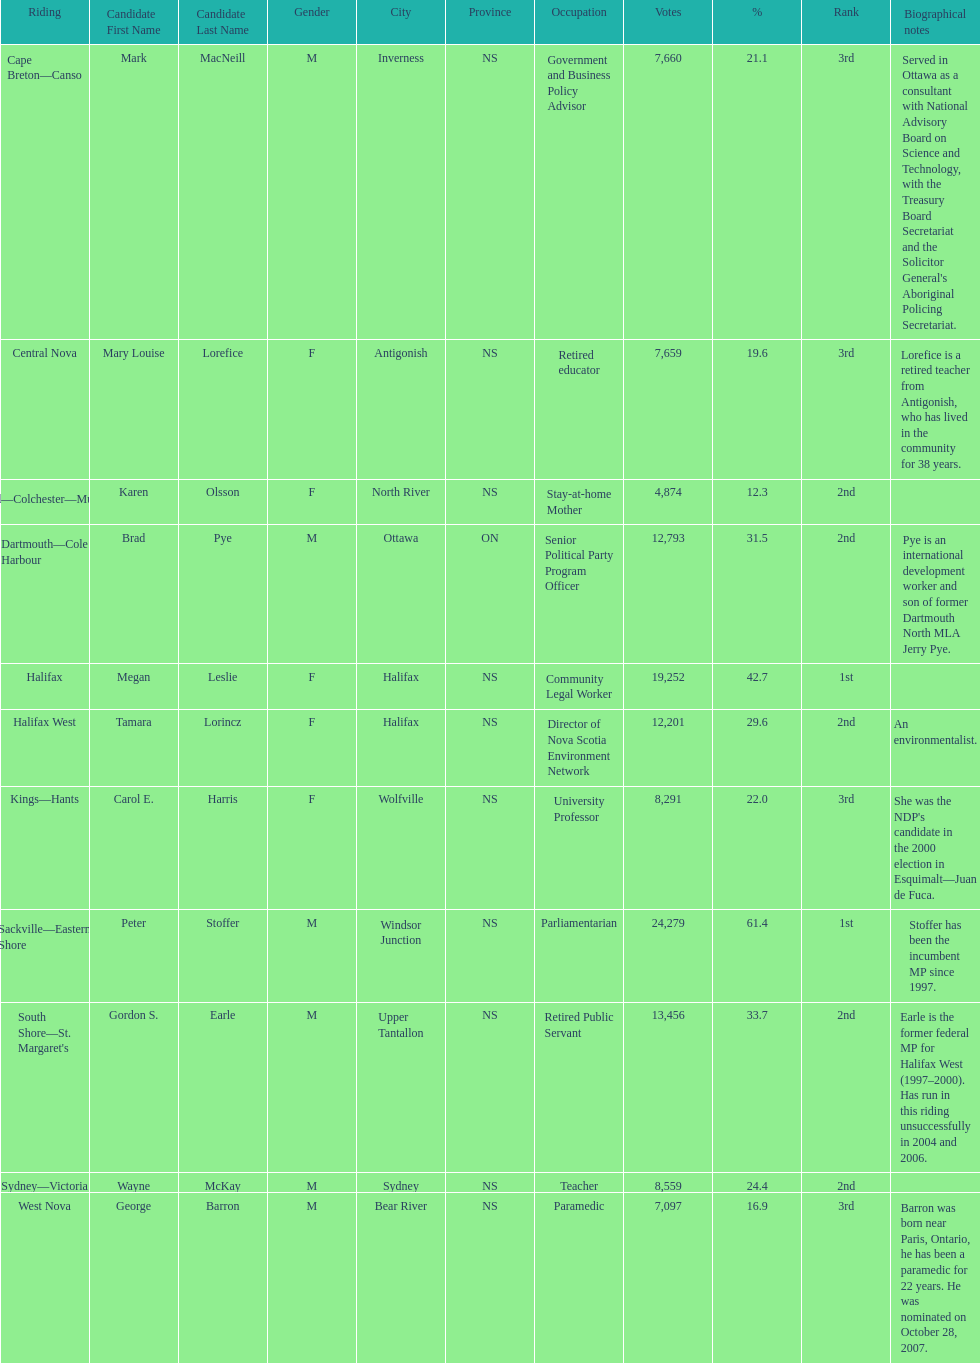Who were all of the new democratic party candidates during the 2008 canadian federal election? Mark MacNeill, Mary Louise Lorefice, Karen Olsson, Brad Pye, Megan Leslie, Tamara Lorincz, Carol E. Harris, Peter Stoffer, Gordon S. Earle, Wayne McKay, George Barron. And between mark macneill and karen olsson, which candidate received more votes? Mark MacNeill. 